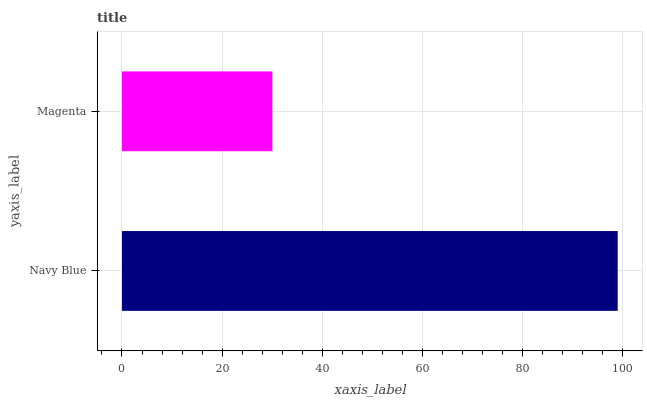Is Magenta the minimum?
Answer yes or no. Yes. Is Navy Blue the maximum?
Answer yes or no. Yes. Is Magenta the maximum?
Answer yes or no. No. Is Navy Blue greater than Magenta?
Answer yes or no. Yes. Is Magenta less than Navy Blue?
Answer yes or no. Yes. Is Magenta greater than Navy Blue?
Answer yes or no. No. Is Navy Blue less than Magenta?
Answer yes or no. No. Is Navy Blue the high median?
Answer yes or no. Yes. Is Magenta the low median?
Answer yes or no. Yes. Is Magenta the high median?
Answer yes or no. No. Is Navy Blue the low median?
Answer yes or no. No. 